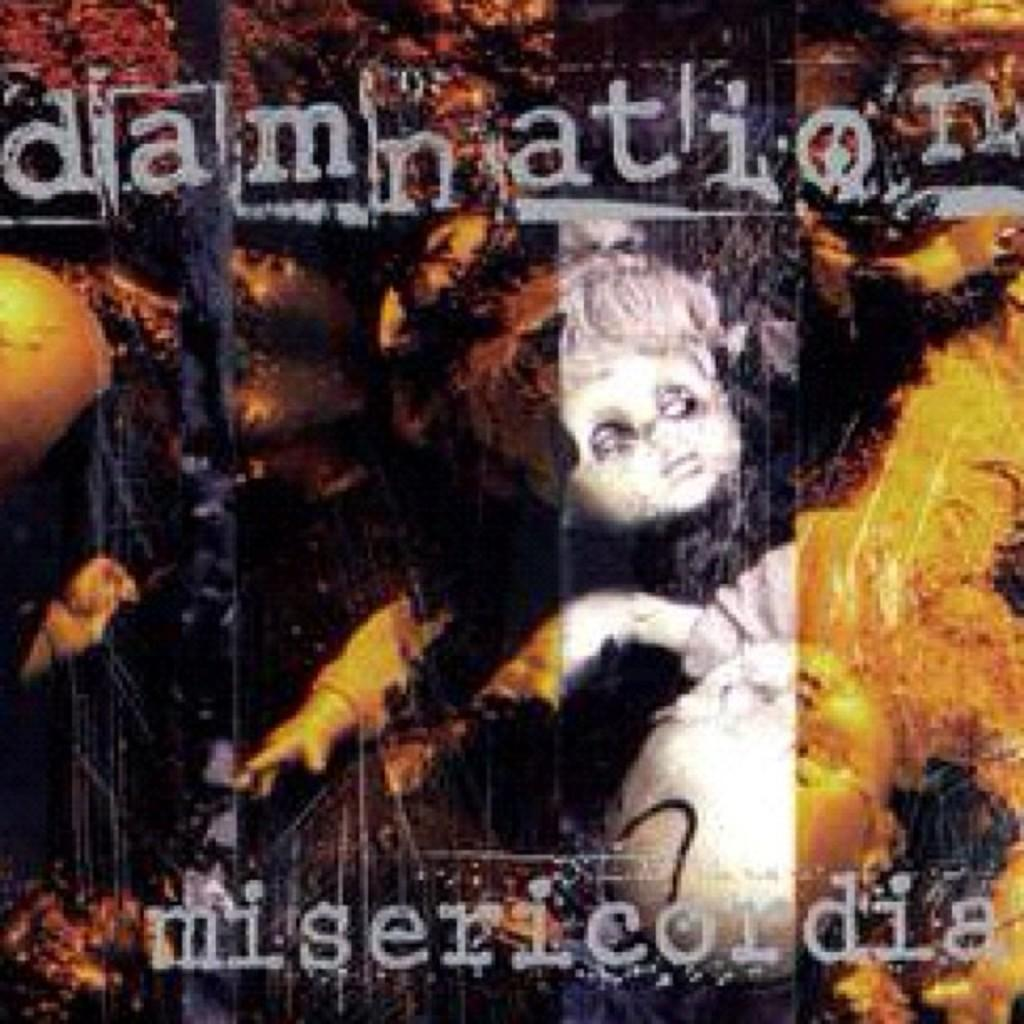What is featured on the poster in the image? The poster contains images of dolls. Is there any text on the poster? Yes, there is text written on the poster. What type of mind can be seen reading the poster in the image? There is no mind or person present in the image; it only features a poster with images of dolls and text. 